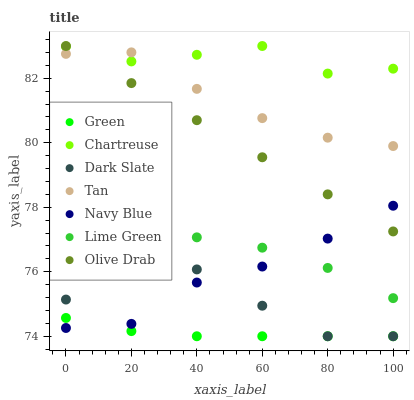Does Green have the minimum area under the curve?
Answer yes or no. Yes. Does Chartreuse have the maximum area under the curve?
Answer yes or no. Yes. Does Dark Slate have the minimum area under the curve?
Answer yes or no. No. Does Dark Slate have the maximum area under the curve?
Answer yes or no. No. Is Olive Drab the smoothest?
Answer yes or no. Yes. Is Dark Slate the roughest?
Answer yes or no. Yes. Is Chartreuse the smoothest?
Answer yes or no. No. Is Chartreuse the roughest?
Answer yes or no. No. Does Dark Slate have the lowest value?
Answer yes or no. Yes. Does Chartreuse have the lowest value?
Answer yes or no. No. Does Olive Drab have the highest value?
Answer yes or no. Yes. Does Dark Slate have the highest value?
Answer yes or no. No. Is Dark Slate less than Tan?
Answer yes or no. Yes. Is Olive Drab greater than Lime Green?
Answer yes or no. Yes. Does Navy Blue intersect Lime Green?
Answer yes or no. Yes. Is Navy Blue less than Lime Green?
Answer yes or no. No. Is Navy Blue greater than Lime Green?
Answer yes or no. No. Does Dark Slate intersect Tan?
Answer yes or no. No. 